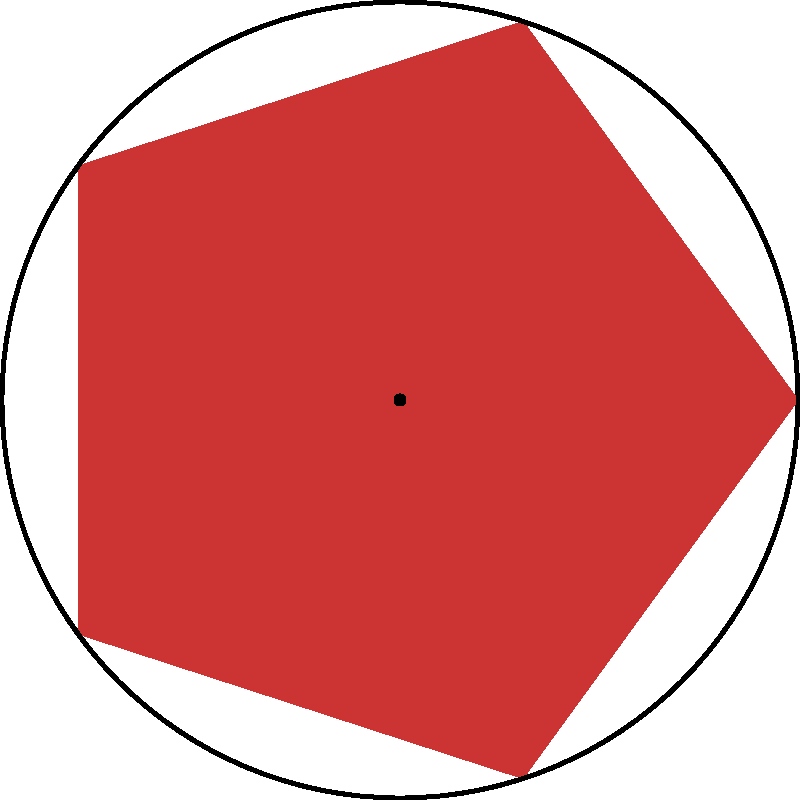Рассмотрите традиционный русский узор в форме пятиконечной звезды, вписанной в круг. Сколько различных положений может принять этот узор при вращении вокруг центра, чтобы он выглядел идентично исходному положению? Чтобы решить эту задачу, нужно следовать следующим шагам:

1) Сначала определим порядок поворотной симметрии узора. Порядок поворотной симметрии - это количество различных положений, которые фигура может принять при вращении вокруг центра, выглядя при этом идентично исходному положению.

2) В данном случае у нас пятиконечная звезда. Это означает, что узор имеет 5 одинаковых "лучей".

3) При повороте на $\frac{360°}{5} = 72°$ узор будет выглядеть точно так же, как в исходном положении.

4) Полный оборот составляет 360°. Чтобы найти количество различных положений, нужно разделить полный оборот на угол, при котором узор повторяется:

   $\frac{360°}{72°} = 5$

5) Также нужно учесть исходное положение. Таким образом, общее количество положений, включая исходное, равно 5.

Следовательно, узор может принять 5 различных положений при вращении вокруг центра, выглядя при этом идентично исходному положению.
Answer: 5 